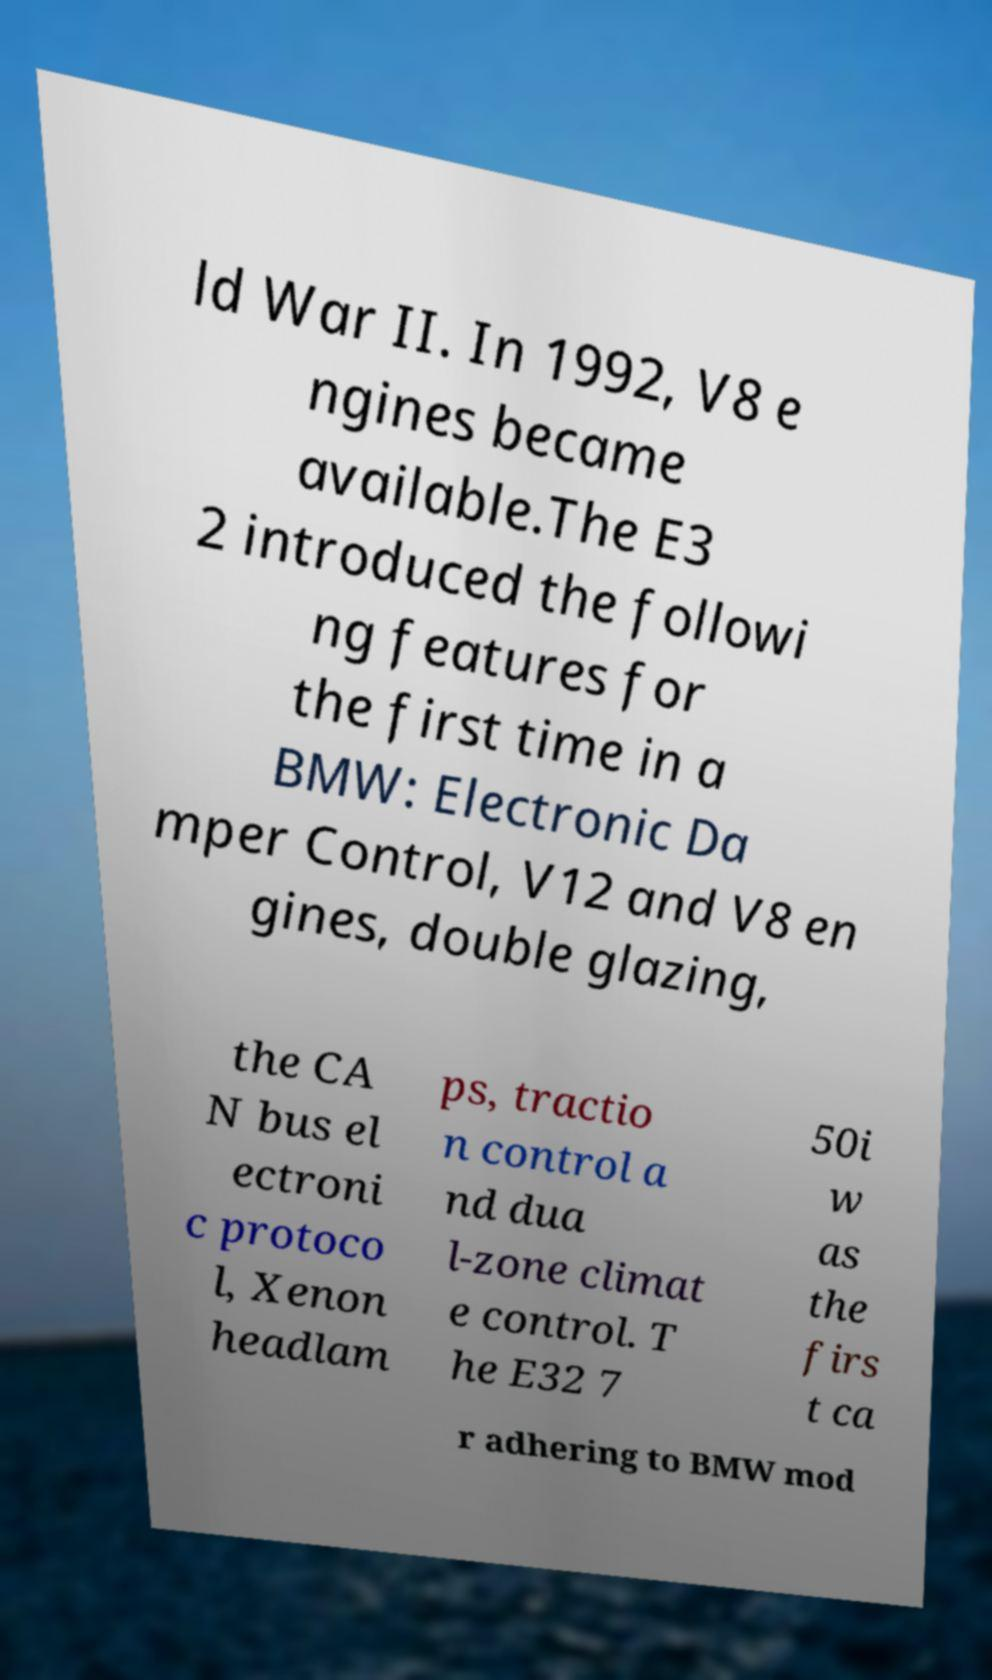Can you accurately transcribe the text from the provided image for me? ld War II. In 1992, V8 e ngines became available.The E3 2 introduced the followi ng features for the first time in a BMW: Electronic Da mper Control, V12 and V8 en gines, double glazing, the CA N bus el ectroni c protoco l, Xenon headlam ps, tractio n control a nd dua l-zone climat e control. T he E32 7 50i w as the firs t ca r adhering to BMW mod 